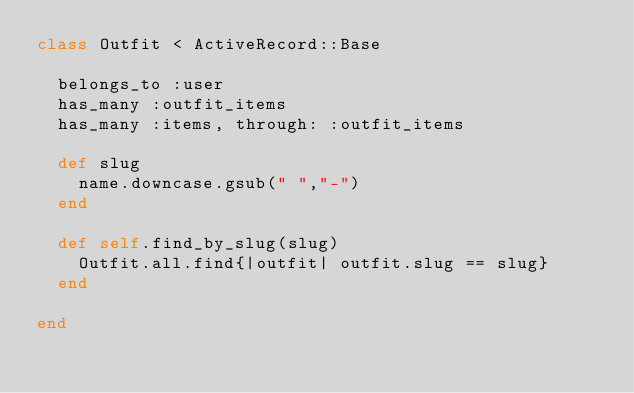Convert code to text. <code><loc_0><loc_0><loc_500><loc_500><_Ruby_>class Outfit < ActiveRecord::Base

  belongs_to :user
  has_many :outfit_items
  has_many :items, through: :outfit_items

  def slug
    name.downcase.gsub(" ","-")
  end

  def self.find_by_slug(slug)
    Outfit.all.find{|outfit| outfit.slug == slug}
  end

end
</code> 